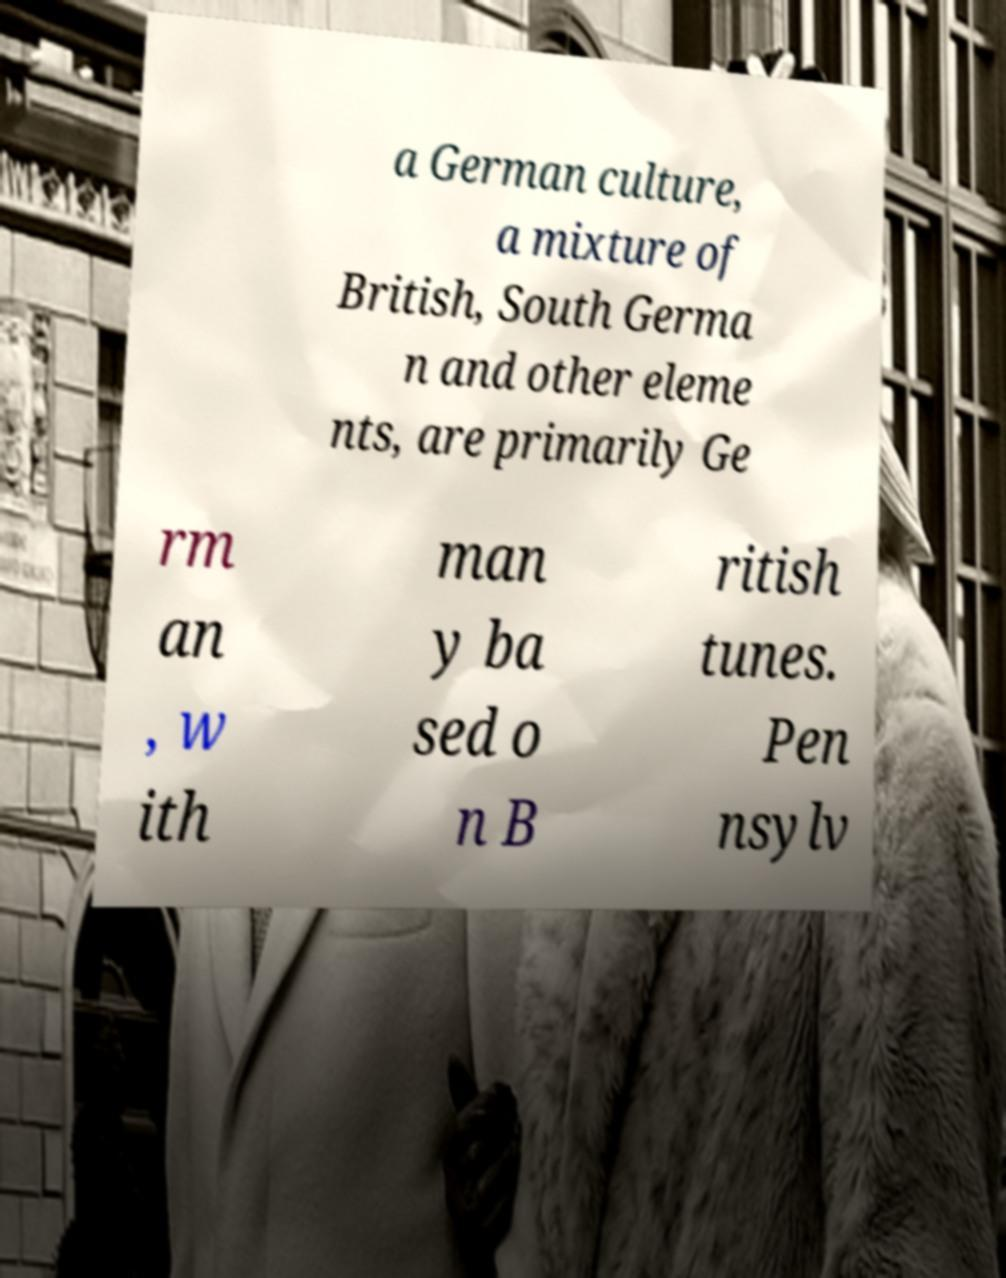Please read and relay the text visible in this image. What does it say? a German culture, a mixture of British, South Germa n and other eleme nts, are primarily Ge rm an , w ith man y ba sed o n B ritish tunes. Pen nsylv 